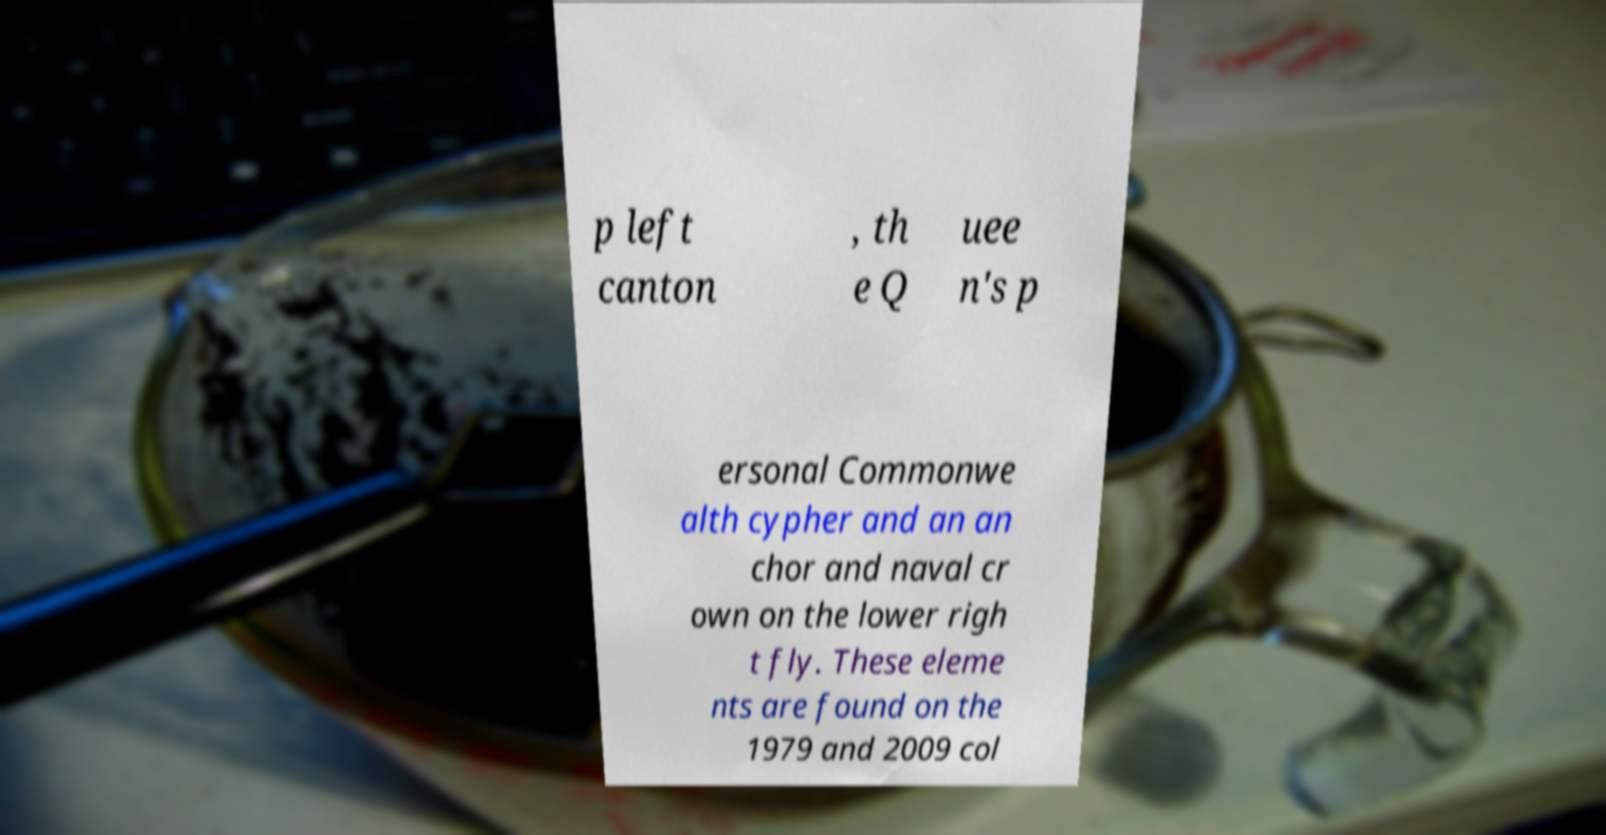Please read and relay the text visible in this image. What does it say? p left canton , th e Q uee n's p ersonal Commonwe alth cypher and an an chor and naval cr own on the lower righ t fly. These eleme nts are found on the 1979 and 2009 col 